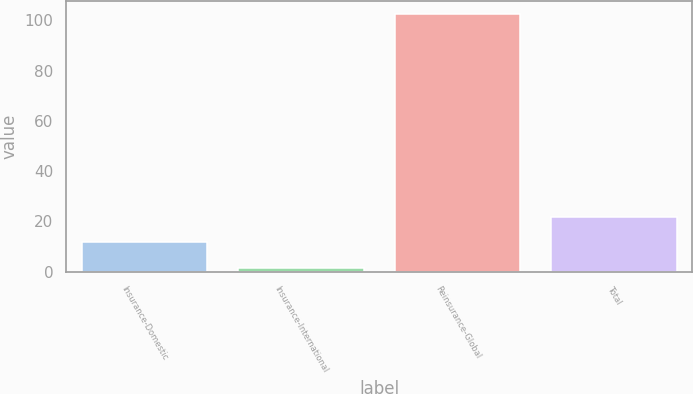Convert chart. <chart><loc_0><loc_0><loc_500><loc_500><bar_chart><fcel>Insurance-Domestic<fcel>Insurance-International<fcel>Reinsurance-Global<fcel>Total<nl><fcel>11.7<fcel>1.6<fcel>102.6<fcel>21.8<nl></chart> 